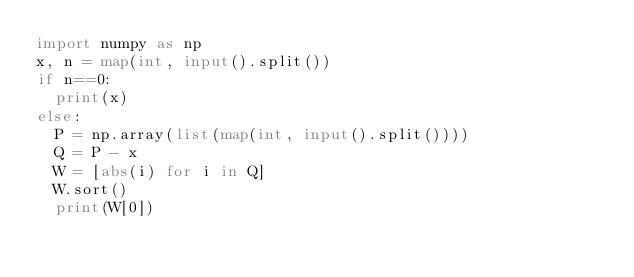<code> <loc_0><loc_0><loc_500><loc_500><_Python_>import numpy as np
x, n = map(int, input().split())
if n==0:
  print(x)
else:
  P = np.array(list(map(int, input().split())))
  Q = P - x
  W = [abs(i) for i in Q]
  W.sort()
  print(W[0])</code> 